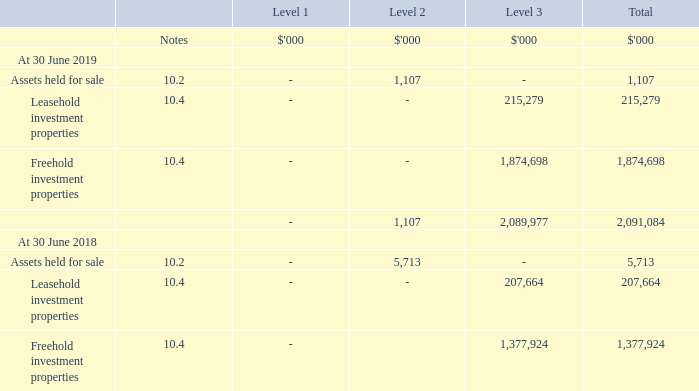10.8. Non-financial assets fair value measurement
The Group has classified its non-financial assets held at fair value into the three levels prescribed in note 9.8 to provide an indication about the reliability of inputs used to determine fair value.
Recognised fair value measurements
The Group’s policy is to recognise transfers into and out of fair value hierarchy levels at the end of the reporting period. There were no transfers between levels 1 and 2 for recurring fair value measurements during the year. During the year ended 30 June 2019 the Group transferred $2.1m from level 3 to level 2 following the reclassification of assets from freehold investment properties to assets held for sale, and $5.7m from level 2 to level 3 following the reclassification of assets from assets held for sale to freehold investment properties, as detailed in note 10.2.
In the prior year ended 30 June 2018 the Group transferred $4.4m from level 3 to level 2 following the reclassification of an asset from freehold investment properties to assets held for sale.
Fair value measurements using significant observable inputs (level 2)
The fair value of assets held for sale is determined using valuation techniques which maximise the use of observable market data. For the years ended 30 June 2019 and 30 June 2018, the Group has valued assets classified as held for sale at the contractually agreed sales price less estimated cost of sale or other observable evidence of market value.
Fair value measurements using significant unobservable inputs (level 3)
Valuation techniques used to determine level 3 fair values and valuation process Investment properties, principally storage buildings, are held for rental to customers requiring selfstorage facilities and are carried at fair value. Changes in fair values are presented in profit or loss as fair value adjustments.
Fair values are determined by a combination of independent valuations and Director valuations. The independent valuations are performed by an accredited independent valuer. Investment properties are independently valued on a rotational basis every three years unless the underlying financing requires a more frequent valuation cycle. For properties subject to an independent valuation report the Directors verify all major inputs to the valuation and review the results with the independent valuer. The Director valuations are completed by the NSH Group Board. The valuations are determined using the same techniques and similar estimates to those applied by the independent valuer.
The Group obtains the majority of its external independent valuations at each financial year end. The Group’s policy is to maintain the valuation of the investment property valued in the preceding year at external valuation, unless there is an indication of a significant change to the property’s valuation inputs.
What was the amount of transfer that the Group did from level 3 to level 2? $2.1m. How has the group valued the assets classified as held for sale in 2018 and 2019? Classified as held for sale at the contractually agreed sales price less estimated cost of sale or other observable evidence of market value. What was the assets held for sale under Level 1, Level 2 and Level 3 in 2018?
Answer scale should be: thousand. -, 5,713, -. What was the change in the assets held for sale under Level 2 from 2018 to 2019?
Answer scale should be: thousand. 1,107 - 5,713
Answer: -4606. In which year was Assets held for sale less than 2,000 thousands? Locate and analyze assets held for sale in row 5 and 10
answer: 2019. What is the average Leasehold investment properties for 2018 and 2019?
Answer scale should be: thousand. (215,279 + 207,664) / 2
Answer: 211471.5. 